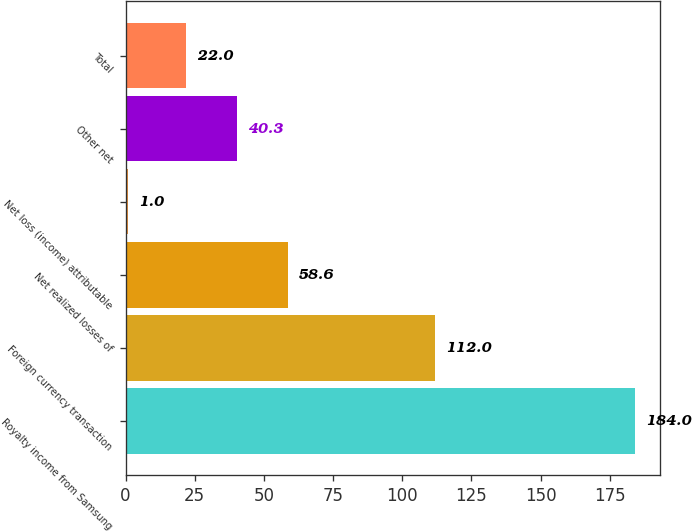Convert chart. <chart><loc_0><loc_0><loc_500><loc_500><bar_chart><fcel>Royalty income from Samsung<fcel>Foreign currency transaction<fcel>Net realized losses of<fcel>Net loss (income) attributable<fcel>Other net<fcel>Total<nl><fcel>184<fcel>112<fcel>58.6<fcel>1<fcel>40.3<fcel>22<nl></chart> 